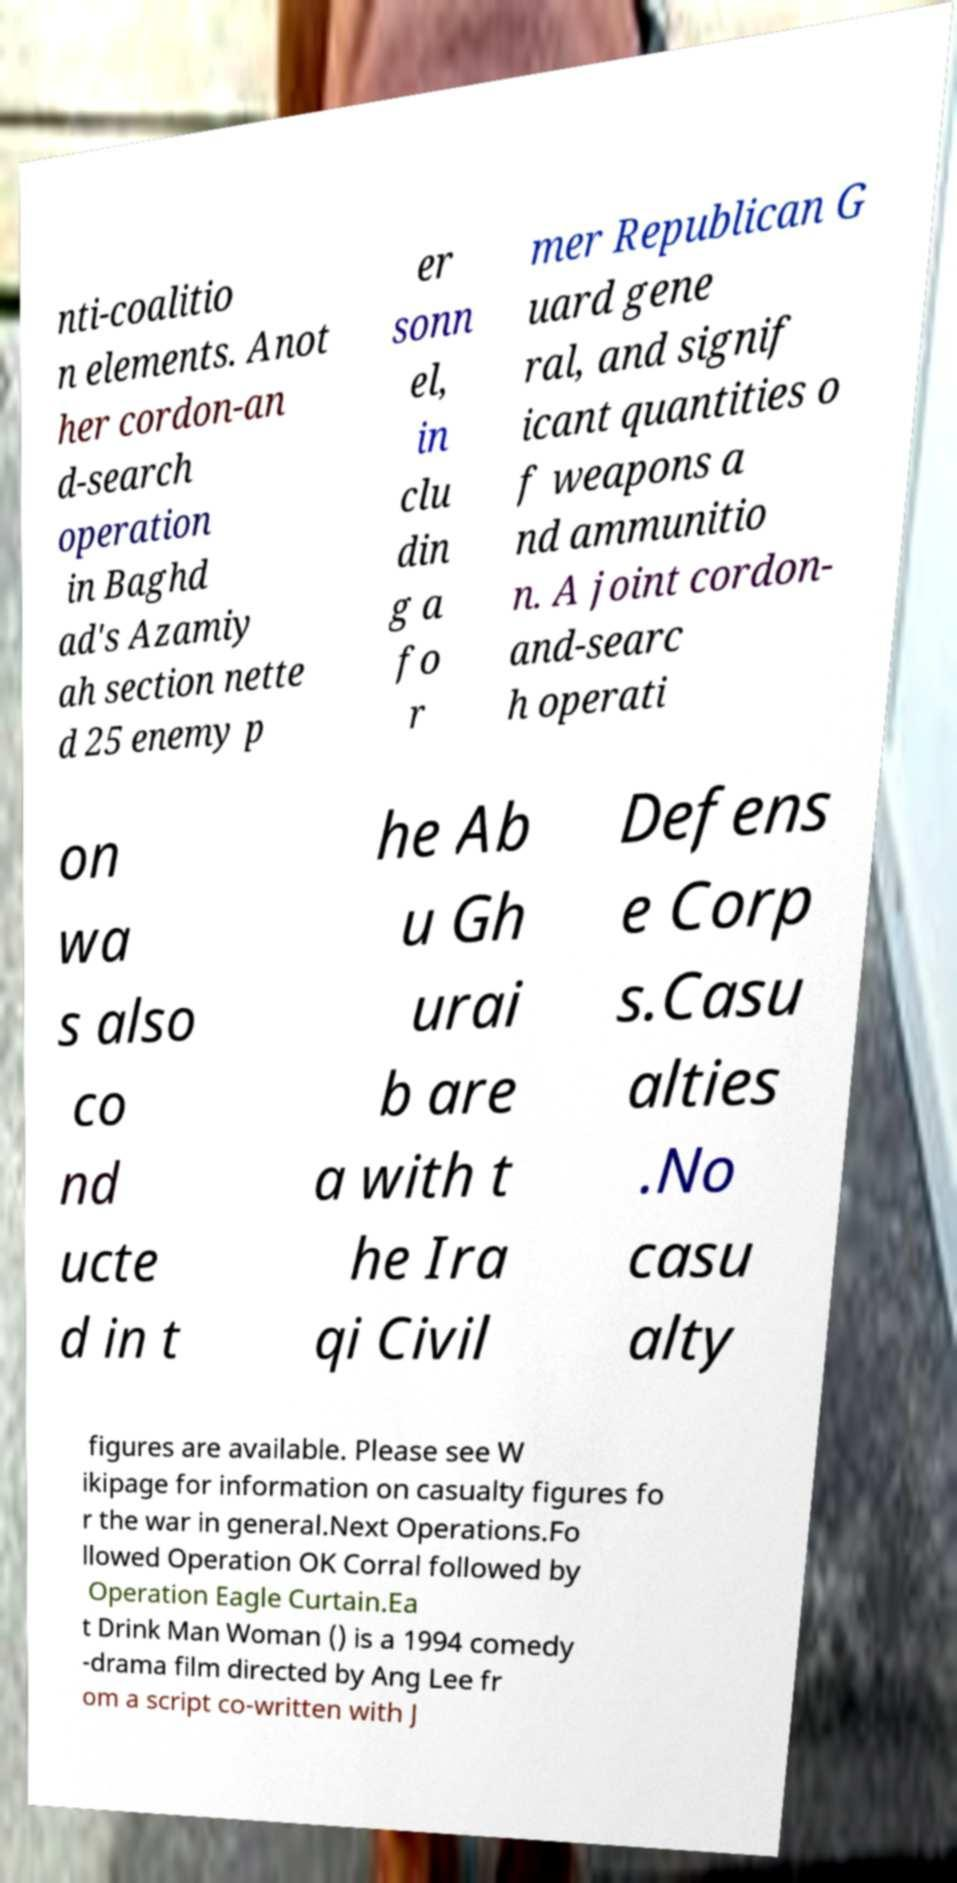I need the written content from this picture converted into text. Can you do that? nti-coalitio n elements. Anot her cordon-an d-search operation in Baghd ad's Azamiy ah section nette d 25 enemy p er sonn el, in clu din g a fo r mer Republican G uard gene ral, and signif icant quantities o f weapons a nd ammunitio n. A joint cordon- and-searc h operati on wa s also co nd ucte d in t he Ab u Gh urai b are a with t he Ira qi Civil Defens e Corp s.Casu alties .No casu alty figures are available. Please see W ikipage for information on casualty figures fo r the war in general.Next Operations.Fo llowed Operation OK Corral followed by Operation Eagle Curtain.Ea t Drink Man Woman () is a 1994 comedy -drama film directed by Ang Lee fr om a script co-written with J 